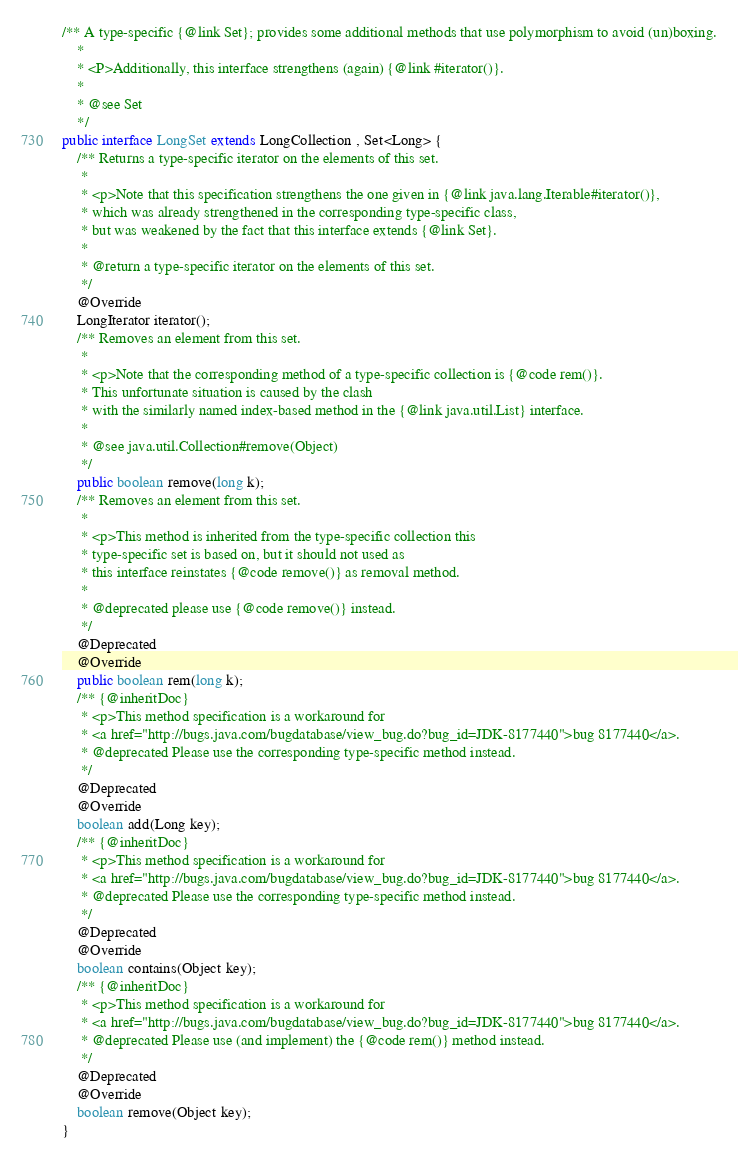<code> <loc_0><loc_0><loc_500><loc_500><_Java_>/** A type-specific {@link Set}; provides some additional methods that use polymorphism to avoid (un)boxing.
	*
	* <P>Additionally, this interface strengthens (again) {@link #iterator()}.
	*
	* @see Set
	*/
public interface LongSet extends LongCollection , Set<Long> {
	/** Returns a type-specific iterator on the elements of this set.
	 *
	 * <p>Note that this specification strengthens the one given in {@link java.lang.Iterable#iterator()},
	 * which was already strengthened in the corresponding type-specific class,
	 * but was weakened by the fact that this interface extends {@link Set}.
	 *
	 * @return a type-specific iterator on the elements of this set.
	 */
	@Override
	LongIterator iterator();
	/** Removes an element from this set.
	 *
	 * <p>Note that the corresponding method of a type-specific collection is {@code rem()}.
	 * This unfortunate situation is caused by the clash
	 * with the similarly named index-based method in the {@link java.util.List} interface.
	 *
	 * @see java.util.Collection#remove(Object)
	 */
	public boolean remove(long k);
	/** Removes an element from this set.
	 *
	 * <p>This method is inherited from the type-specific collection this
	 * type-specific set is based on, but it should not used as
	 * this interface reinstates {@code remove()} as removal method.
	 *
	 * @deprecated please use {@code remove()} instead.
	 */
	@Deprecated
	@Override
	public boolean rem(long k);
	/** {@inheritDoc}
	 * <p>This method specification is a workaround for
	 * <a href="http://bugs.java.com/bugdatabase/view_bug.do?bug_id=JDK-8177440">bug 8177440</a>.
	 * @deprecated Please use the corresponding type-specific method instead.
	 */
	@Deprecated
	@Override
	boolean add(Long key);
	/** {@inheritDoc}
	 * <p>This method specification is a workaround for
	 * <a href="http://bugs.java.com/bugdatabase/view_bug.do?bug_id=JDK-8177440">bug 8177440</a>.
	 * @deprecated Please use the corresponding type-specific method instead.
	 */
	@Deprecated
	@Override
	boolean contains(Object key);
	/** {@inheritDoc}
	 * <p>This method specification is a workaround for
	 * <a href="http://bugs.java.com/bugdatabase/view_bug.do?bug_id=JDK-8177440">bug 8177440</a>.
	 * @deprecated Please use (and implement) the {@code rem()} method instead.
	 */
	@Deprecated
	@Override
	boolean remove(Object key);
}
</code> 